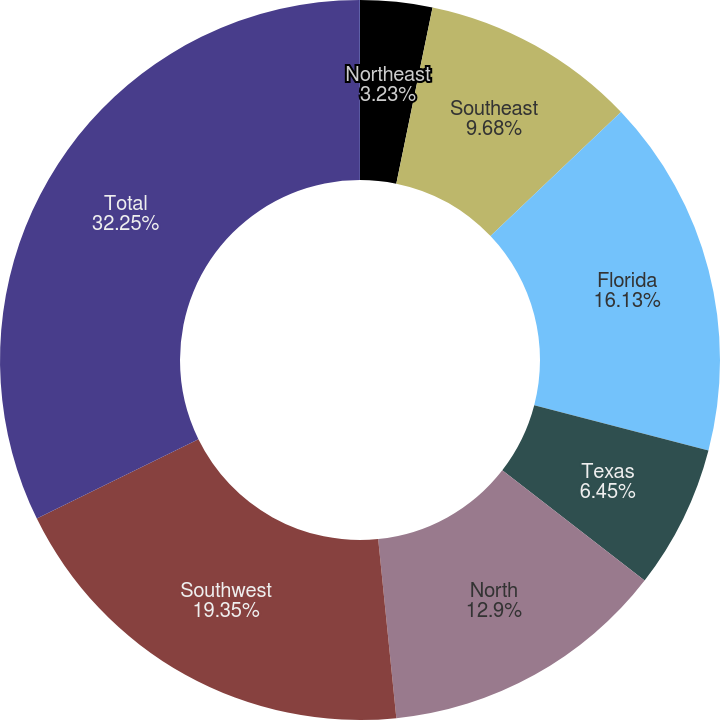Convert chart to OTSL. <chart><loc_0><loc_0><loc_500><loc_500><pie_chart><fcel>Northeast<fcel>Southeast<fcel>Florida<fcel>Texas<fcel>North<fcel>Southwest<fcel>Total<fcel>Developed ()<nl><fcel>3.23%<fcel>9.68%<fcel>16.13%<fcel>6.45%<fcel>12.9%<fcel>19.35%<fcel>32.25%<fcel>0.01%<nl></chart> 